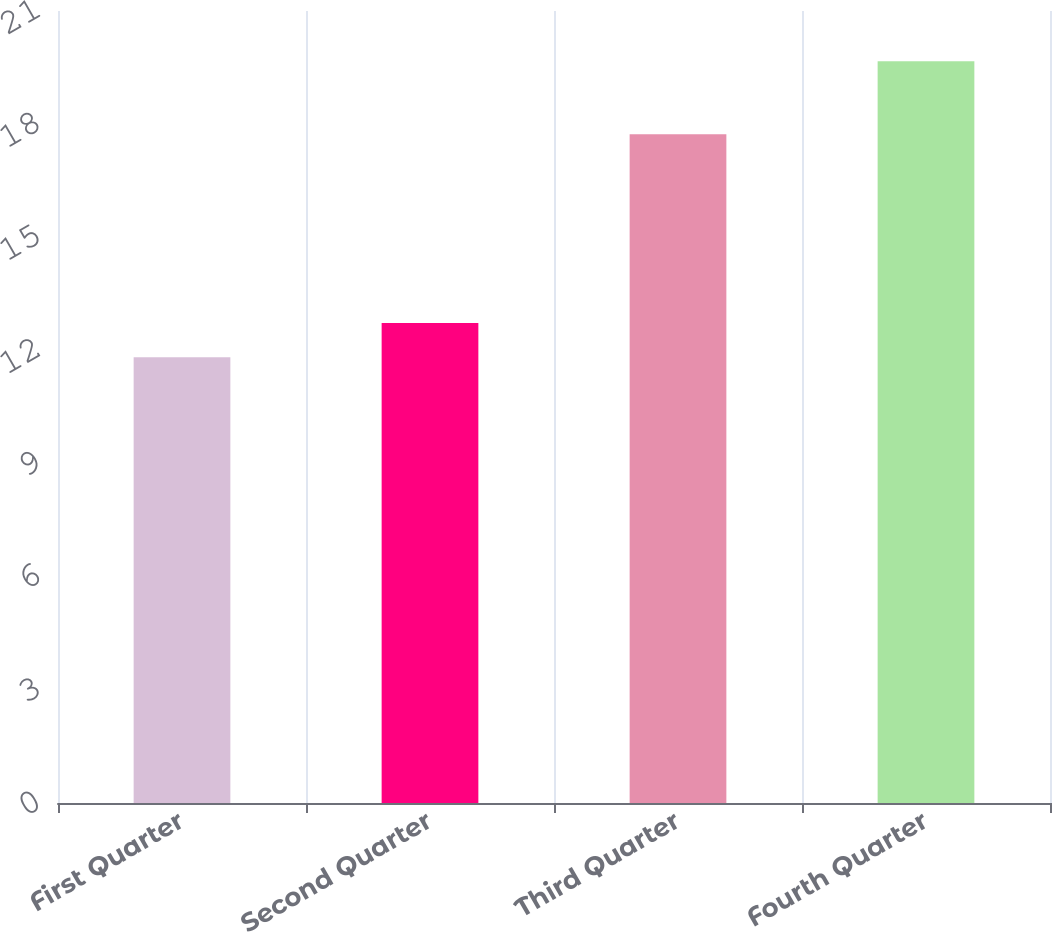<chart> <loc_0><loc_0><loc_500><loc_500><bar_chart><fcel>First Quarter<fcel>Second Quarter<fcel>Third Quarter<fcel>Fourth Quarter<nl><fcel>11.82<fcel>12.73<fcel>17.73<fcel>19.67<nl></chart> 